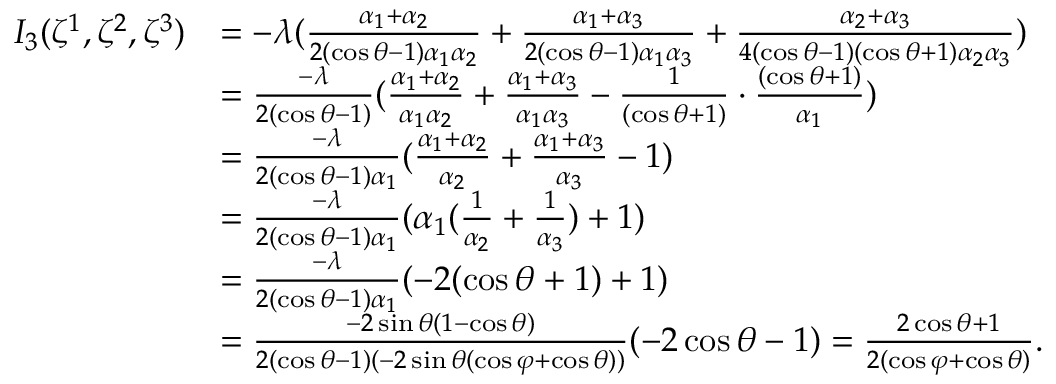Convert formula to latex. <formula><loc_0><loc_0><loc_500><loc_500>\begin{array} { r l } { { I } _ { 3 } ( \zeta ^ { 1 } , \zeta ^ { 2 } , \zeta ^ { 3 } ) } & { = - \lambda ( \frac { \alpha _ { 1 } + \alpha _ { 2 } } { 2 ( \cos \theta - 1 ) \alpha _ { 1 } \alpha _ { 2 } } + \frac { \alpha _ { 1 } + \alpha _ { 3 } } { 2 ( \cos \theta - 1 ) \alpha _ { 1 } \alpha _ { 3 } } + \frac { \alpha _ { 2 } + \alpha _ { 3 } } { 4 ( \cos \theta - 1 ) ( \cos \theta + 1 ) \alpha _ { 2 } \alpha _ { 3 } } ) } \\ & { = \frac { - \lambda } { 2 ( \cos \theta - 1 ) } ( \frac { \alpha _ { 1 } + \alpha _ { 2 } } { \alpha _ { 1 } \alpha _ { 2 } } + \frac { \alpha _ { 1 } + \alpha _ { 3 } } { \alpha _ { 1 } \alpha _ { 3 } } - \frac { 1 } { ( \cos \theta + 1 ) } \cdot \frac { ( \cos \theta + 1 ) } { \alpha _ { 1 } } ) } \\ & { = \frac { - \lambda } { 2 ( \cos \theta - 1 ) \alpha _ { 1 } } ( \frac { \alpha _ { 1 } + \alpha _ { 2 } } { \alpha _ { 2 } } + \frac { \alpha _ { 1 } + \alpha _ { 3 } } { \alpha _ { 3 } } - { 1 } ) } \\ & { = \frac { - \lambda } { 2 ( \cos \theta - 1 ) \alpha _ { 1 } } ( \alpha _ { 1 } ( \frac { 1 } { \alpha _ { 2 } } + \frac { 1 } { \alpha _ { 3 } } ) + 1 ) } \\ & { = \frac { - \lambda } { 2 ( \cos \theta - 1 ) \alpha _ { 1 } } ( - { 2 ( \cos \theta + 1 ) } + 1 ) } \\ & { = \frac { - 2 \sin \theta ( 1 - \cos \theta ) } { 2 ( \cos \theta - 1 ) ( - 2 \sin \theta ( \cos \varphi + \cos \theta ) ) } ( - 2 \cos \theta - 1 ) = \frac { 2 \cos \theta + 1 } { 2 ( \cos \varphi + \cos \theta ) } . } \end{array}</formula> 